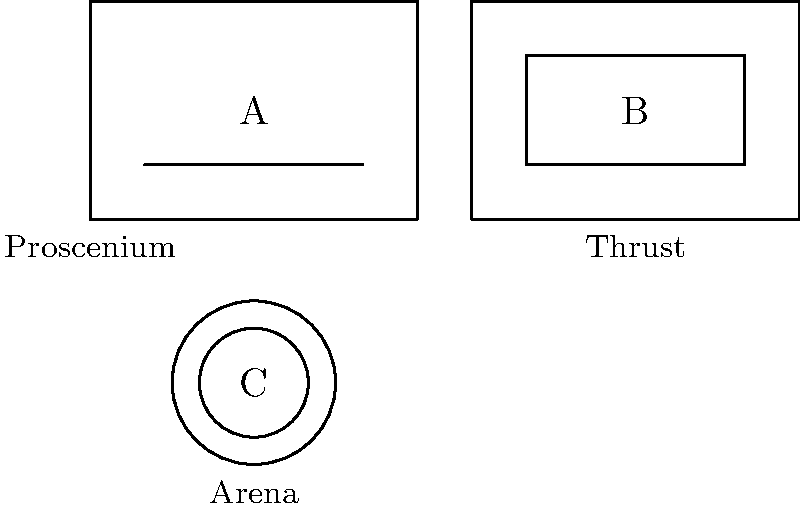As a Theater major, identify which stage layout (A, B, or C) represents a thrust stage configuration. To identify the thrust stage configuration, let's analyze each layout:

1. Layout A:
   - Rectangular shape
   - Single straight line at the front
   - This represents a proscenium stage, where the audience sits on one side

2. Layout B:
   - Rectangular shape
   - Three sides extend into the audience area
   - This is characteristic of a thrust stage, where the audience surrounds the stage on three sides

3. Layout C:
   - Circular shape
   - Audience completely surrounds the performance area
   - This represents an arena stage (also known as theater-in-the-round)

The thrust stage is characterized by its extension into the audience, creating a more immersive experience while still maintaining a "back" to the stage. This description matches Layout B in the diagram.
Answer: B 